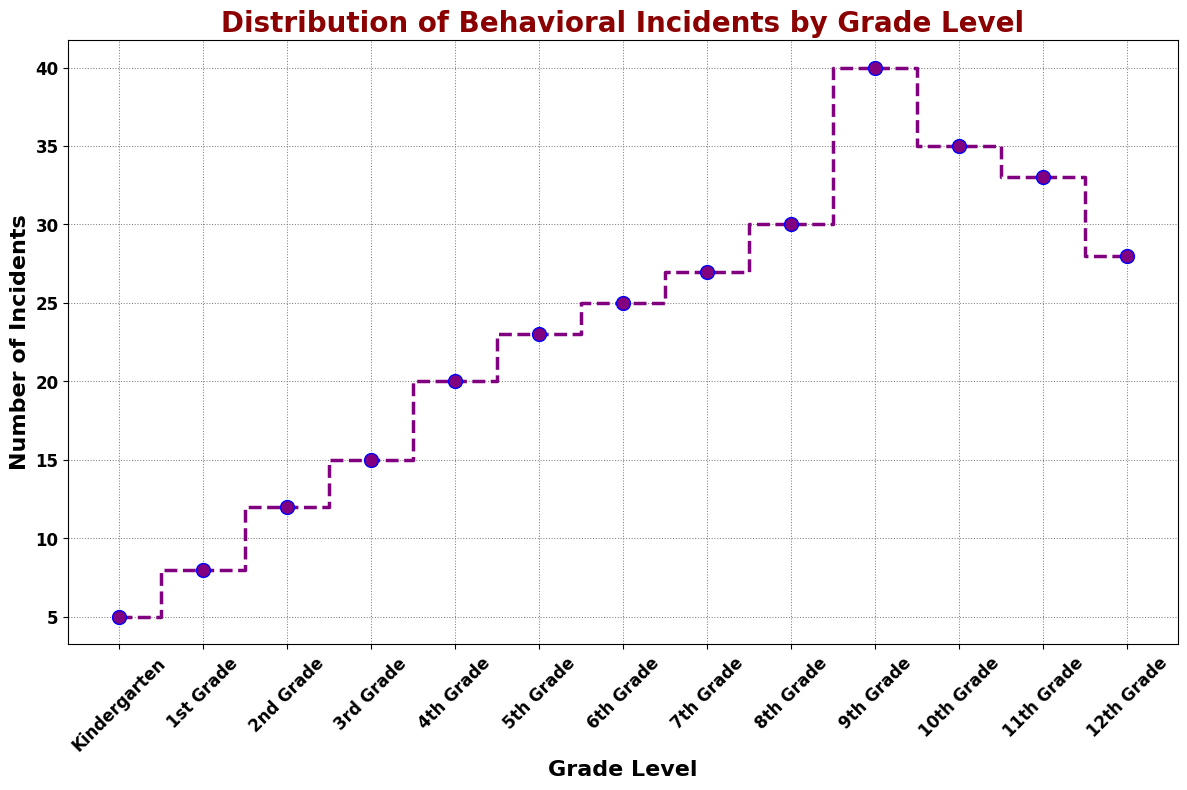What is the total number of behavioral incidents from Kindergarten to 6th Grade? Add the incidents from Kindergarten to 6th Grade: 5 (Kindergarten) + 8 (1st Grade) + 12 (2nd Grade) + 15 (3rd Grade) + 20 (4th Grade) + 23 (5th Grade) + 25 (6th Grade) = 108
Answer: 108 Which grade level has the highest number of incidents? The highest point on the stairs plot corresponds to 9th Grade with 40 incidents
Answer: 9th Grade How many more incidents occur in 9th Grade compared to 10th Grade? Subtract the number of incidents in 10th Grade from 9th Grade: 40 (9th Grade) - 35 (10th Grade) = 5
Answer: 5 What is the difference in the number of incidents between the grade with the fewest incidents and the grade with the most incidents? Subtract the smallest number of incidents (Kindergarten, 5) from the largest number (9th Grade, 40): 40 - 5 = 35
Answer: 35 How do incidents change from 8th Grade to 9th Grade? Compare the number of incidents in both grades: 9th Grade has 40 incidents and 8th Grade has 30, so there is an increase of 10 incidents
Answer: Increase by 10 Which grade levels have fewer incidents than 11th Grade? Identify grades with incidents less than 33 (11th Grade): Kindergarten (5), 1st (8), 2nd (12), 3rd (15), 4th (20), 5th (23), 6th (25), 7th (27), 8th (30)
Answer: Kindergarten, 1st, 2nd, 3rd, 4th, 5th, 6th, 7th, 8th What is the average number of incidents from Kindergarten to 12th Grade? Sum all incidents and divide by the number of grades: (5 + 8 + 12 + 15 + 20 + 23 + 25 + 27 + 30 + 40 + 35 + 33 + 28) / 13 = 301 / 13 ≈ 23.15
Answer: 23.15 How much do incidents decrease from 9th Grade to 12th Grade? Subtract the number of incidents in 12th Grade from 9th Grade: 40 (9th Grade) - 28 (12th Grade) = 12
Answer: 12 Which color represents the stairs plot for the number of incidents? The stairs plot is outlined in purple with blue marker edges, clearly shown by the visual attributes
Answer: Purple with blue edges 